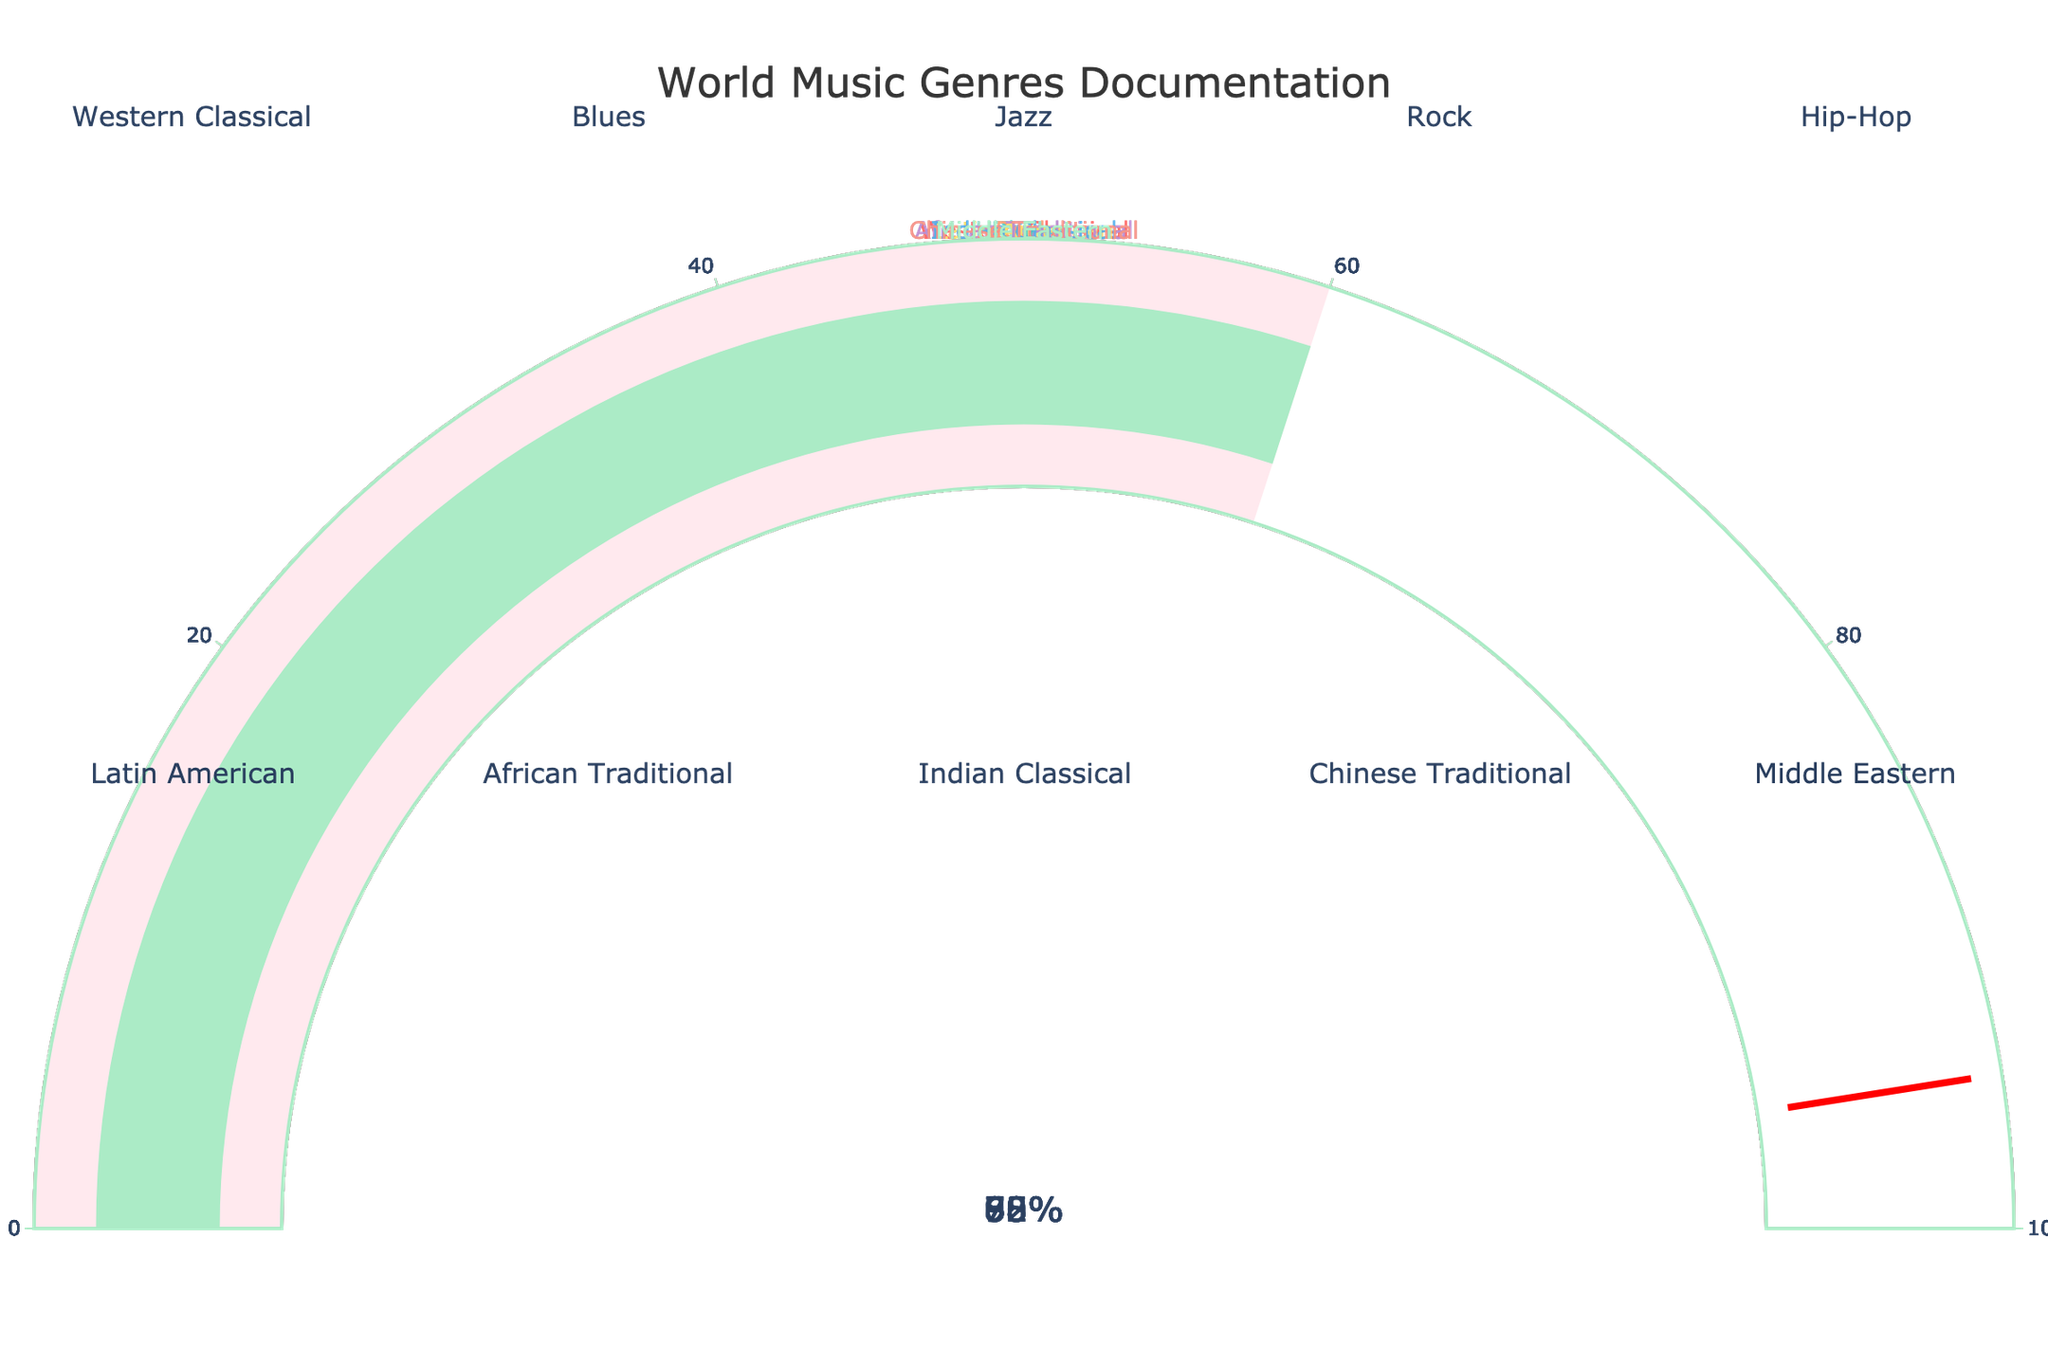Which genre has the highest documentation percentage? The gauge chart shows multiple genres with their corresponding documentation percentages. The highest documentation percentage is shown on the gauge for Rock with 90%.
Answer: Rock Which genre has the lowest documentation percentage? Looking at the gauge chart, the genre with the lowest percentage is Middle Eastern, which has a documentation percentage of 60%.
Answer: Middle Eastern What is the average documentation percentage of all the genres? To find the average documentation percentage, sum all the percentages and divide by the number of genres. (85 + 78 + 82 + 90 + 88 + 70 + 65 + 72 + 68 + 60) / 10 = 75.8%
Answer: 75.8% Which genres have a documentation percentage greater than 80%? By observing the gauges, the genres with documentation percentages greater than 80% are Western Classical (85%), Jazz (82%), Rock (90%), and Hip-Hop (88%).
Answer: Western Classical, Jazz, Rock, Hip-Hop What's the total documentation percentage for genres classified as traditional music? Traditional music genres in the figure are African Traditional (65%), Chinese Traditional (68%), and Middle Eastern (60%). Their total documentation percentage is 65 + 68 + 60 = 193%.
Answer: 193% How much more documented is Rock compared to Middle Eastern music? Rock has a documentation percentage of 90%, while Middle Eastern has 60%. The difference is 90 - 60 = 30%.
Answer: 30% What is the median documentation percentage of the genres? To calculate the median: List the percentages in ascending order: 60, 65, 68, 70, 72, 78, 82, 85, 88, 90. The middle values are 72 and 78, so the median is (72 + 78) / 2 = 75%.
Answer: 75% Which genre has a documentation percentage closest to 75%? By comparing each percentage with 75%, Indian Classical (72%) is the closest.
Answer: Indian Classical How many genres have a documentation percentage less than 70%? By counting the number of gauges with percentages less than 70%, there are four: Latin American (70%), African Traditional (65%), Chinese Traditional (68%), and Middle Eastern (60%).
Answer: 4 Is the documentation percentage for Hip-Hop higher than that for Blues? The documentation percentage for Hip-Hop is 88% and for Blues is 78%. Yes, Hip-Hop is higher than Blues.
Answer: Yes 